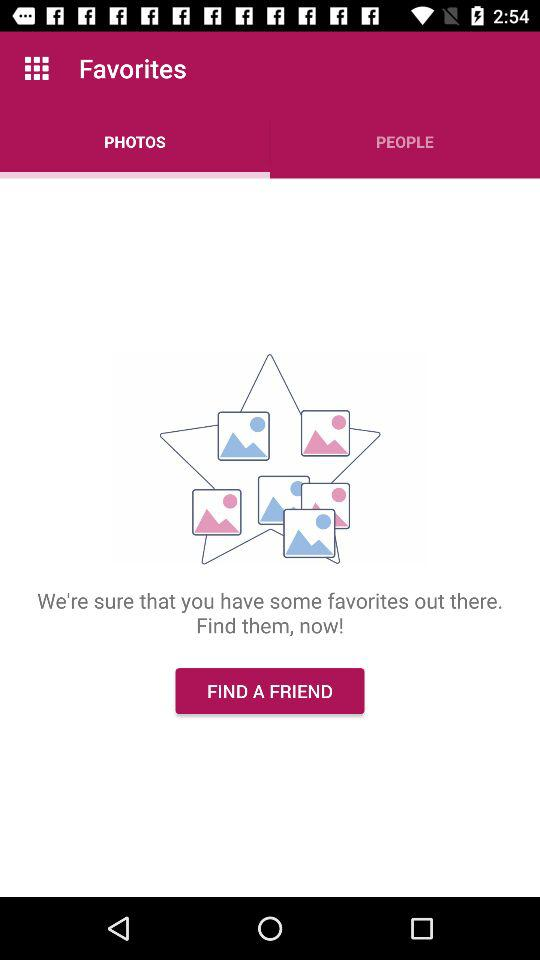Which tab is selected? The selected tab is "PHOTOS". 